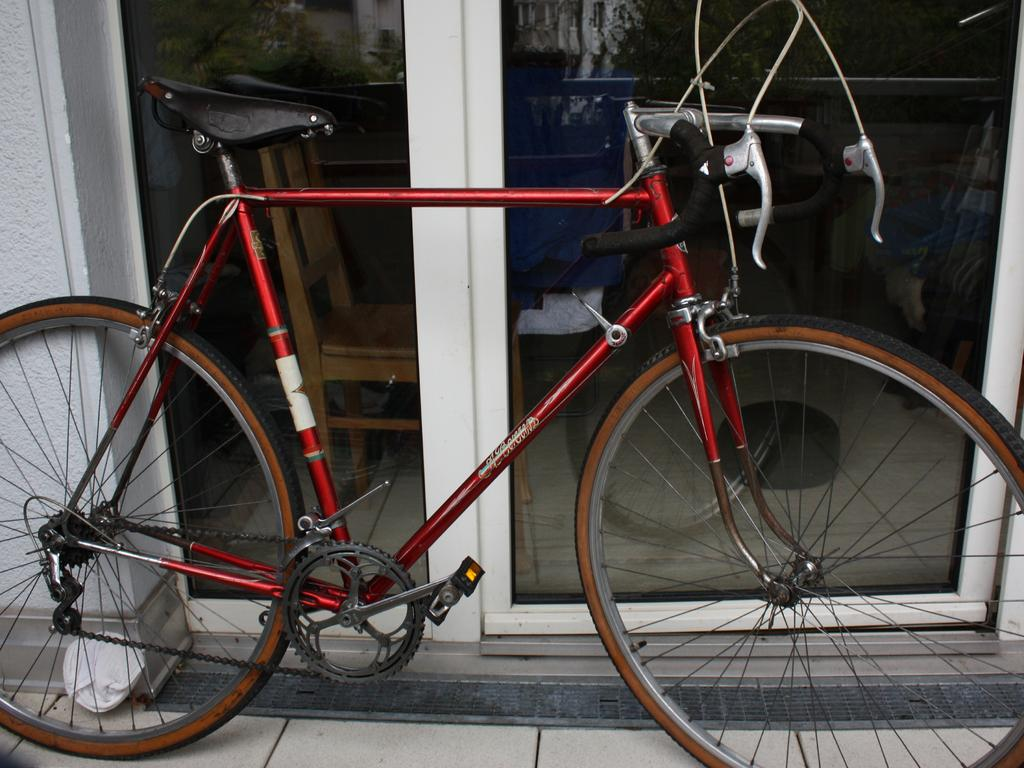What is the main object in the image? There is a bicycle in the image. Where is the bicycle located? The bicycle is parked on the pavement. What is nearby the bicycle? The bicycle is near a glass door. What can be seen through the glass door? There is a chair visible through the glass door. What type of farm animals can be seen grazing near the bicycle in the image? There are no farm animals present in the image; it features a bicycle parked on the pavement near a glass door. 